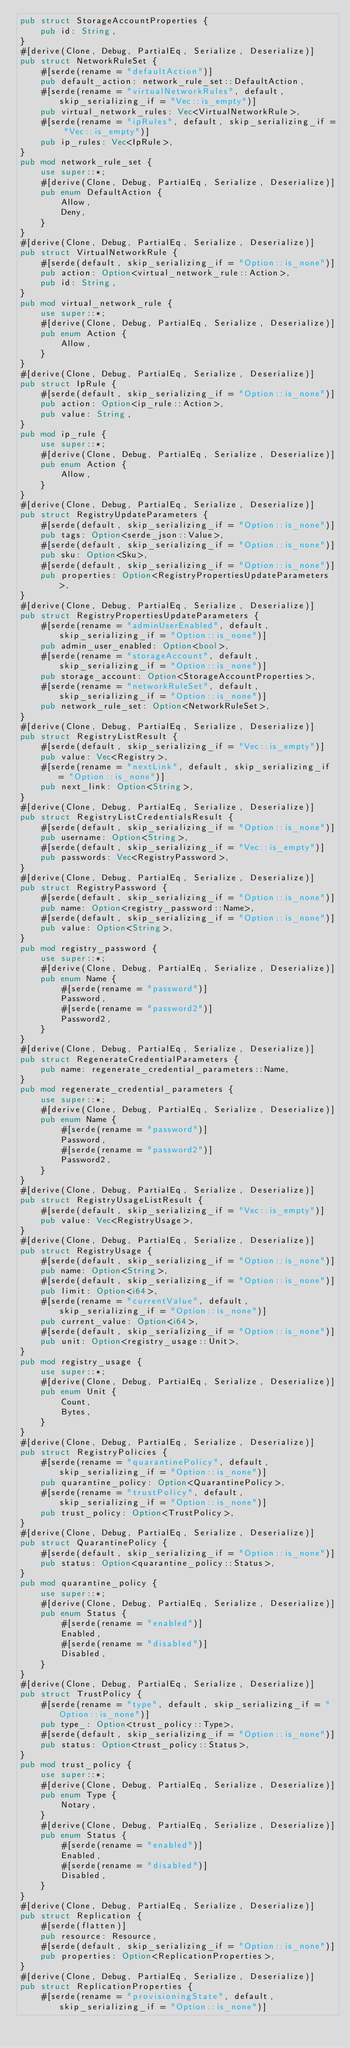<code> <loc_0><loc_0><loc_500><loc_500><_Rust_>pub struct StorageAccountProperties {
    pub id: String,
}
#[derive(Clone, Debug, PartialEq, Serialize, Deserialize)]
pub struct NetworkRuleSet {
    #[serde(rename = "defaultAction")]
    pub default_action: network_rule_set::DefaultAction,
    #[serde(rename = "virtualNetworkRules", default, skip_serializing_if = "Vec::is_empty")]
    pub virtual_network_rules: Vec<VirtualNetworkRule>,
    #[serde(rename = "ipRules", default, skip_serializing_if = "Vec::is_empty")]
    pub ip_rules: Vec<IpRule>,
}
pub mod network_rule_set {
    use super::*;
    #[derive(Clone, Debug, PartialEq, Serialize, Deserialize)]
    pub enum DefaultAction {
        Allow,
        Deny,
    }
}
#[derive(Clone, Debug, PartialEq, Serialize, Deserialize)]
pub struct VirtualNetworkRule {
    #[serde(default, skip_serializing_if = "Option::is_none")]
    pub action: Option<virtual_network_rule::Action>,
    pub id: String,
}
pub mod virtual_network_rule {
    use super::*;
    #[derive(Clone, Debug, PartialEq, Serialize, Deserialize)]
    pub enum Action {
        Allow,
    }
}
#[derive(Clone, Debug, PartialEq, Serialize, Deserialize)]
pub struct IpRule {
    #[serde(default, skip_serializing_if = "Option::is_none")]
    pub action: Option<ip_rule::Action>,
    pub value: String,
}
pub mod ip_rule {
    use super::*;
    #[derive(Clone, Debug, PartialEq, Serialize, Deserialize)]
    pub enum Action {
        Allow,
    }
}
#[derive(Clone, Debug, PartialEq, Serialize, Deserialize)]
pub struct RegistryUpdateParameters {
    #[serde(default, skip_serializing_if = "Option::is_none")]
    pub tags: Option<serde_json::Value>,
    #[serde(default, skip_serializing_if = "Option::is_none")]
    pub sku: Option<Sku>,
    #[serde(default, skip_serializing_if = "Option::is_none")]
    pub properties: Option<RegistryPropertiesUpdateParameters>,
}
#[derive(Clone, Debug, PartialEq, Serialize, Deserialize)]
pub struct RegistryPropertiesUpdateParameters {
    #[serde(rename = "adminUserEnabled", default, skip_serializing_if = "Option::is_none")]
    pub admin_user_enabled: Option<bool>,
    #[serde(rename = "storageAccount", default, skip_serializing_if = "Option::is_none")]
    pub storage_account: Option<StorageAccountProperties>,
    #[serde(rename = "networkRuleSet", default, skip_serializing_if = "Option::is_none")]
    pub network_rule_set: Option<NetworkRuleSet>,
}
#[derive(Clone, Debug, PartialEq, Serialize, Deserialize)]
pub struct RegistryListResult {
    #[serde(default, skip_serializing_if = "Vec::is_empty")]
    pub value: Vec<Registry>,
    #[serde(rename = "nextLink", default, skip_serializing_if = "Option::is_none")]
    pub next_link: Option<String>,
}
#[derive(Clone, Debug, PartialEq, Serialize, Deserialize)]
pub struct RegistryListCredentialsResult {
    #[serde(default, skip_serializing_if = "Option::is_none")]
    pub username: Option<String>,
    #[serde(default, skip_serializing_if = "Vec::is_empty")]
    pub passwords: Vec<RegistryPassword>,
}
#[derive(Clone, Debug, PartialEq, Serialize, Deserialize)]
pub struct RegistryPassword {
    #[serde(default, skip_serializing_if = "Option::is_none")]
    pub name: Option<registry_password::Name>,
    #[serde(default, skip_serializing_if = "Option::is_none")]
    pub value: Option<String>,
}
pub mod registry_password {
    use super::*;
    #[derive(Clone, Debug, PartialEq, Serialize, Deserialize)]
    pub enum Name {
        #[serde(rename = "password")]
        Password,
        #[serde(rename = "password2")]
        Password2,
    }
}
#[derive(Clone, Debug, PartialEq, Serialize, Deserialize)]
pub struct RegenerateCredentialParameters {
    pub name: regenerate_credential_parameters::Name,
}
pub mod regenerate_credential_parameters {
    use super::*;
    #[derive(Clone, Debug, PartialEq, Serialize, Deserialize)]
    pub enum Name {
        #[serde(rename = "password")]
        Password,
        #[serde(rename = "password2")]
        Password2,
    }
}
#[derive(Clone, Debug, PartialEq, Serialize, Deserialize)]
pub struct RegistryUsageListResult {
    #[serde(default, skip_serializing_if = "Vec::is_empty")]
    pub value: Vec<RegistryUsage>,
}
#[derive(Clone, Debug, PartialEq, Serialize, Deserialize)]
pub struct RegistryUsage {
    #[serde(default, skip_serializing_if = "Option::is_none")]
    pub name: Option<String>,
    #[serde(default, skip_serializing_if = "Option::is_none")]
    pub limit: Option<i64>,
    #[serde(rename = "currentValue", default, skip_serializing_if = "Option::is_none")]
    pub current_value: Option<i64>,
    #[serde(default, skip_serializing_if = "Option::is_none")]
    pub unit: Option<registry_usage::Unit>,
}
pub mod registry_usage {
    use super::*;
    #[derive(Clone, Debug, PartialEq, Serialize, Deserialize)]
    pub enum Unit {
        Count,
        Bytes,
    }
}
#[derive(Clone, Debug, PartialEq, Serialize, Deserialize)]
pub struct RegistryPolicies {
    #[serde(rename = "quarantinePolicy", default, skip_serializing_if = "Option::is_none")]
    pub quarantine_policy: Option<QuarantinePolicy>,
    #[serde(rename = "trustPolicy", default, skip_serializing_if = "Option::is_none")]
    pub trust_policy: Option<TrustPolicy>,
}
#[derive(Clone, Debug, PartialEq, Serialize, Deserialize)]
pub struct QuarantinePolicy {
    #[serde(default, skip_serializing_if = "Option::is_none")]
    pub status: Option<quarantine_policy::Status>,
}
pub mod quarantine_policy {
    use super::*;
    #[derive(Clone, Debug, PartialEq, Serialize, Deserialize)]
    pub enum Status {
        #[serde(rename = "enabled")]
        Enabled,
        #[serde(rename = "disabled")]
        Disabled,
    }
}
#[derive(Clone, Debug, PartialEq, Serialize, Deserialize)]
pub struct TrustPolicy {
    #[serde(rename = "type", default, skip_serializing_if = "Option::is_none")]
    pub type_: Option<trust_policy::Type>,
    #[serde(default, skip_serializing_if = "Option::is_none")]
    pub status: Option<trust_policy::Status>,
}
pub mod trust_policy {
    use super::*;
    #[derive(Clone, Debug, PartialEq, Serialize, Deserialize)]
    pub enum Type {
        Notary,
    }
    #[derive(Clone, Debug, PartialEq, Serialize, Deserialize)]
    pub enum Status {
        #[serde(rename = "enabled")]
        Enabled,
        #[serde(rename = "disabled")]
        Disabled,
    }
}
#[derive(Clone, Debug, PartialEq, Serialize, Deserialize)]
pub struct Replication {
    #[serde(flatten)]
    pub resource: Resource,
    #[serde(default, skip_serializing_if = "Option::is_none")]
    pub properties: Option<ReplicationProperties>,
}
#[derive(Clone, Debug, PartialEq, Serialize, Deserialize)]
pub struct ReplicationProperties {
    #[serde(rename = "provisioningState", default, skip_serializing_if = "Option::is_none")]</code> 